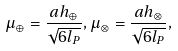<formula> <loc_0><loc_0><loc_500><loc_500>\mu _ { \oplus } = \frac { a h _ { \oplus } } { \sqrt { 6 l _ { P } } } , \mu _ { \otimes } = \frac { a h _ { \otimes } } { \sqrt { 6 l _ { P } } } ,</formula> 